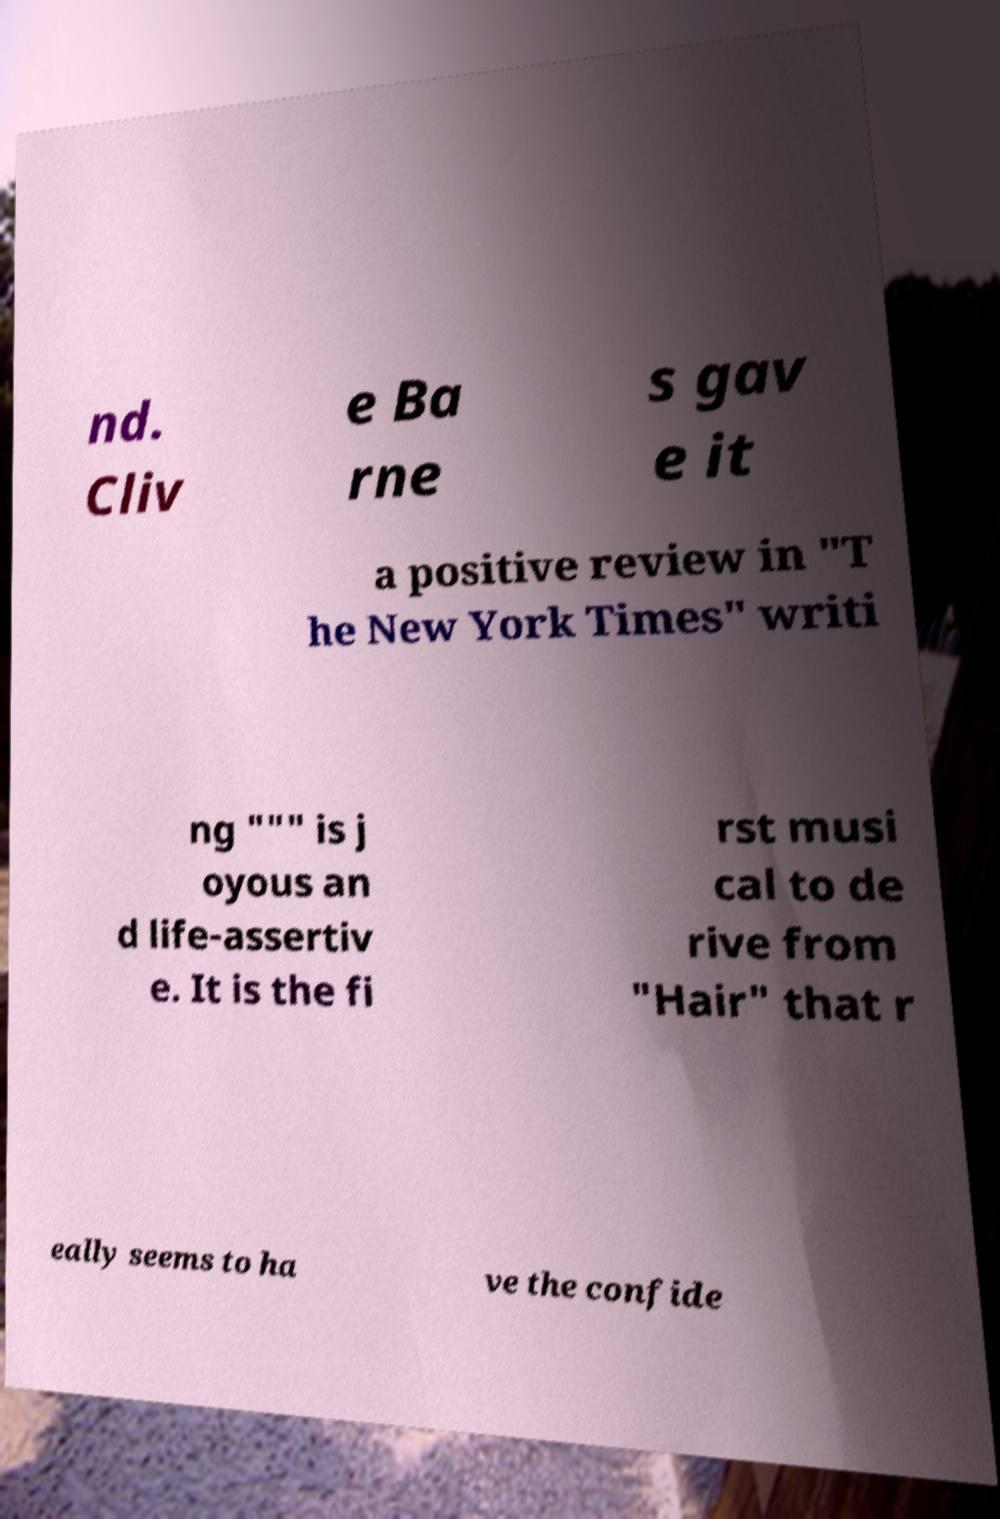Can you accurately transcribe the text from the provided image for me? nd. Cliv e Ba rne s gav e it a positive review in "T he New York Times" writi ng """ is j oyous an d life-assertiv e. It is the fi rst musi cal to de rive from "Hair" that r eally seems to ha ve the confide 